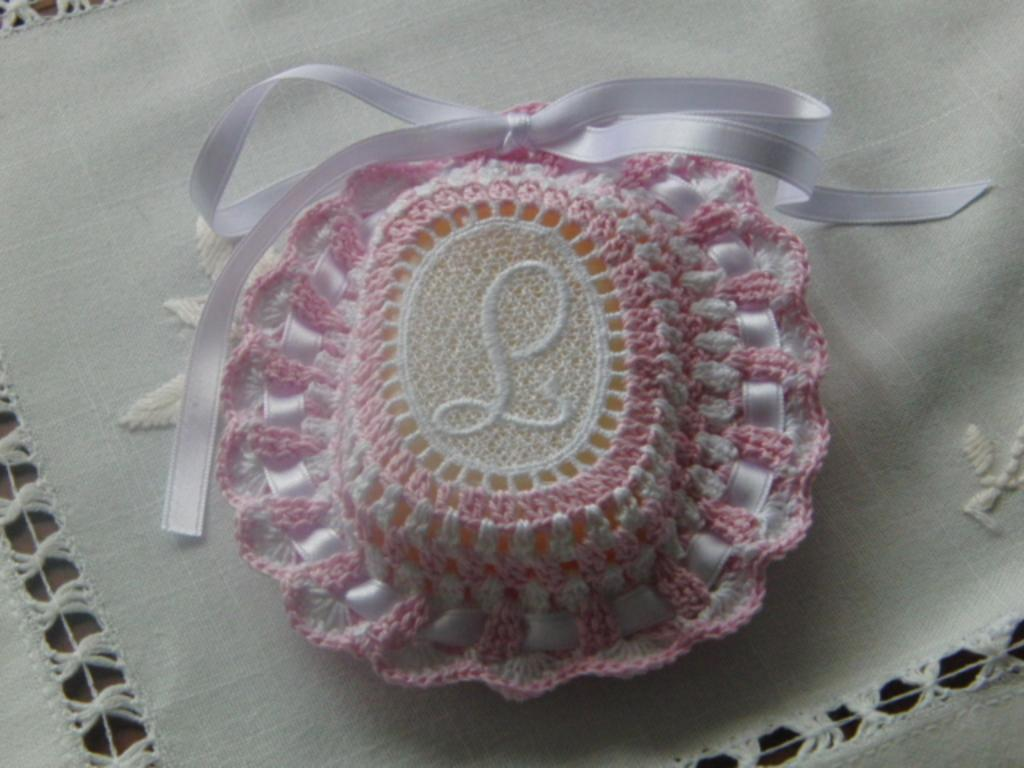What is covering the bottom part of the image? There is a white cloth at the bottom of the image. What can be seen at the top of the white cloth? There is a designed object at the top of the cloth. Is there a crook visible in the image? No, there is no crook present in the image. What type of sail can be seen on the white cloth? There is no sail present in the image; it features a white cloth with a designed object at the top. 